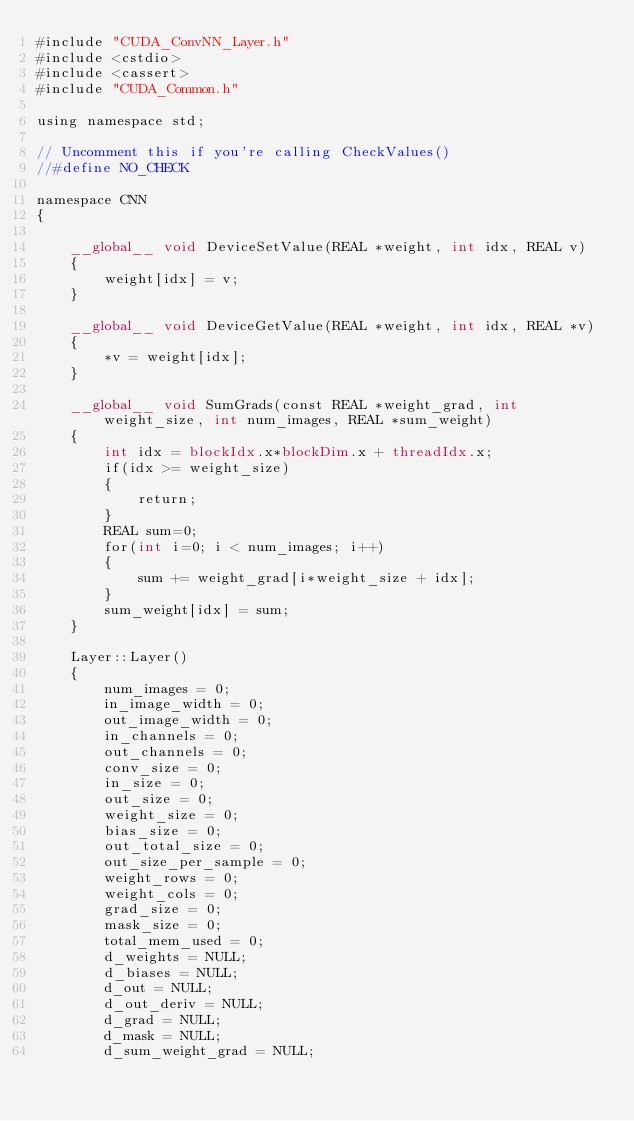Convert code to text. <code><loc_0><loc_0><loc_500><loc_500><_Cuda_>#include "CUDA_ConvNN_Layer.h"
#include <cstdio>
#include <cassert>
#include "CUDA_Common.h"

using namespace std;

// Uncomment this if you're calling CheckValues()
//#define NO_CHECK

namespace CNN
{

	__global__ void DeviceSetValue(REAL *weight, int idx, REAL v)
	{
		weight[idx] = v;
	}

	__global__ void DeviceGetValue(REAL *weight, int idx, REAL *v)
	{
		*v = weight[idx];
	}

	__global__ void SumGrads(const REAL *weight_grad, int weight_size, int num_images, REAL *sum_weight)
	{
		int idx = blockIdx.x*blockDim.x + threadIdx.x;
		if(idx >= weight_size)
		{
			return;
		}
		REAL sum=0;
		for(int i=0; i < num_images; i++)
		{
			sum += weight_grad[i*weight_size + idx];
		}
		sum_weight[idx] = sum;
	}

	Layer::Layer()
	{
		num_images = 0;
		in_image_width = 0;
		out_image_width = 0;
		in_channels = 0;
		out_channels = 0;
		conv_size = 0;
		in_size = 0;
		out_size = 0;
		weight_size = 0;
		bias_size = 0;
		out_total_size = 0;
		out_size_per_sample = 0;
		weight_rows = 0;
		weight_cols = 0;
		grad_size = 0;
		mask_size = 0;
		total_mem_used = 0;
		d_weights = NULL;
		d_biases = NULL;
		d_out = NULL;
		d_out_deriv = NULL;
		d_grad = NULL;
		d_mask = NULL;
		d_sum_weight_grad = NULL;</code> 